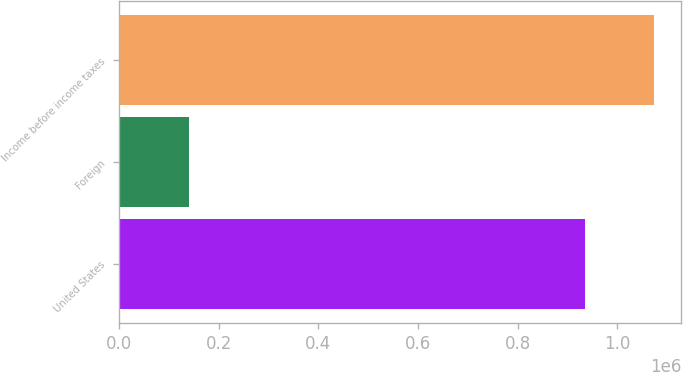Convert chart to OTSL. <chart><loc_0><loc_0><loc_500><loc_500><bar_chart><fcel>United States<fcel>Foreign<fcel>Income before income taxes<nl><fcel>934476<fcel>139864<fcel>1.07434e+06<nl></chart> 